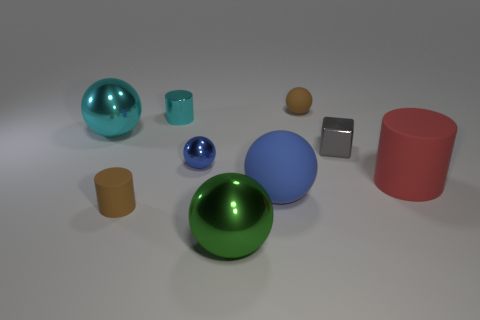Subtract all red rubber cylinders. How many cylinders are left? 2 Add 1 tiny gray blocks. How many objects exist? 10 Subtract all green balls. How many balls are left? 4 Add 2 gray things. How many gray things exist? 3 Subtract 0 yellow blocks. How many objects are left? 9 Subtract all blocks. How many objects are left? 8 Subtract all purple cylinders. Subtract all cyan spheres. How many cylinders are left? 3 Subtract all blue spheres. How many yellow cylinders are left? 0 Subtract all rubber balls. Subtract all green metal balls. How many objects are left? 6 Add 4 small gray shiny cubes. How many small gray shiny cubes are left? 5 